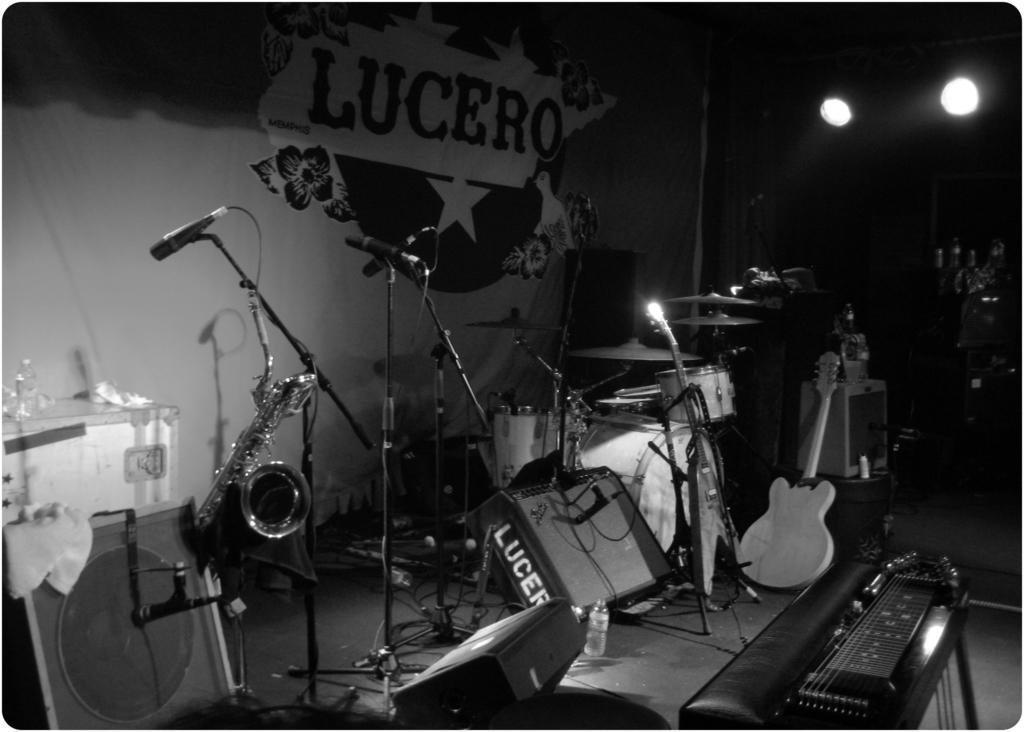What type of objects can be seen in the image? There are musical instruments and microphones in the image. What might the musical instruments be used for? The musical instruments might be used for playing music or performing. What are the microphones likely used for? The microphones are likely used for amplifying sound or recording audio. What type of yam is being used as a prop in the image? There is no yam present in the image; it features musical instruments and microphones. Can you provide a list of educational resources mentioned in the image? There is no mention of educational resources in the image; it focuses on musical instruments and microphones. 